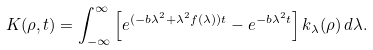Convert formula to latex. <formula><loc_0><loc_0><loc_500><loc_500>K ( \rho , t ) = \int _ { - \infty } ^ { \infty } \left [ e ^ { ( - b \lambda ^ { 2 } + \lambda ^ { 2 } f ( \lambda ) ) t } - e ^ { - b \lambda ^ { 2 } t } \right ] k _ { \lambda } ( \rho ) \, d \lambda .</formula> 